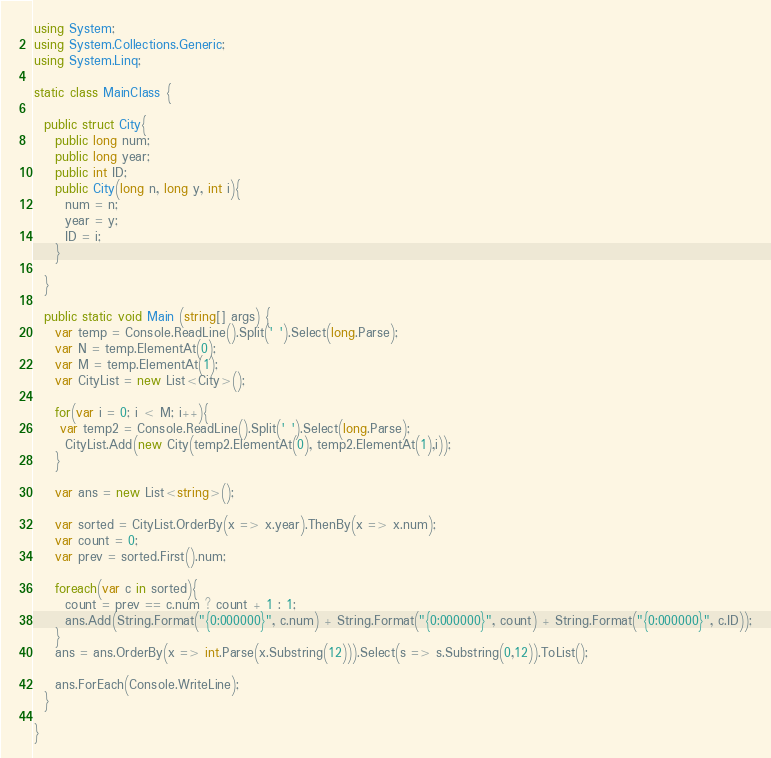<code> <loc_0><loc_0><loc_500><loc_500><_C#_>using System;
using System.Collections.Generic;
using System.Linq;
 
static class MainClass {
 
  public struct City{
    public long num;
    public long year;
    public int ID;
    public City(long n, long y, int i){
      num = n;
      year = y;
      ID = i;
    }

  }

  public static void Main (string[] args) {
    var temp = Console.ReadLine().Split(' ').Select(long.Parse);
    var N = temp.ElementAt(0);
    var M = temp.ElementAt(1);
    var CityList = new List<City>();

    for(var i = 0; i < M; i++){
     var temp2 = Console.ReadLine().Split(' ').Select(long.Parse);
      CityList.Add(new City(temp2.ElementAt(0), temp2.ElementAt(1),i));
    }
    
    var ans = new List<string>();

    var sorted = CityList.OrderBy(x => x.year).ThenBy(x => x.num);
    var count = 0;
    var prev = sorted.First().num;
    
    foreach(var c in sorted){
      count = prev == c.num ? count + 1 : 1;
      ans.Add(String.Format("{0:000000}", c.num) + String.Format("{0:000000}", count) + String.Format("{0:000000}", c.ID));
    }
    ans = ans.OrderBy(x => int.Parse(x.Substring(12))).Select(s => s.Substring(0,12)).ToList();

    ans.ForEach(Console.WriteLine);
  }
  
}</code> 